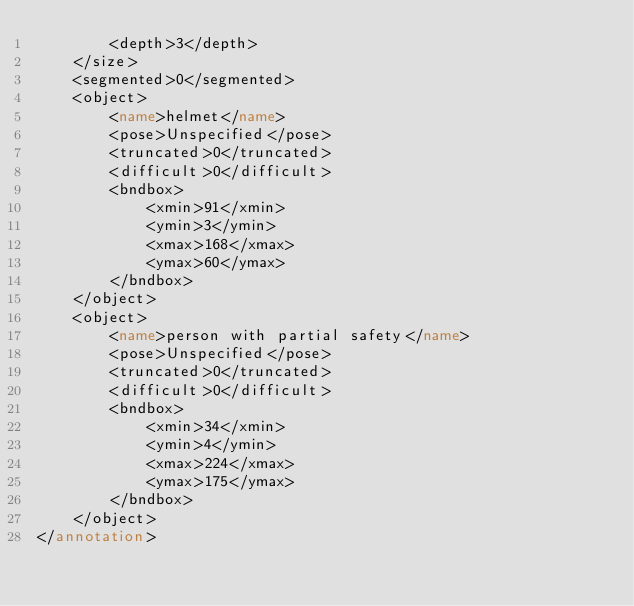Convert code to text. <code><loc_0><loc_0><loc_500><loc_500><_XML_>		<depth>3</depth>
	</size>
	<segmented>0</segmented>
	<object>
		<name>helmet</name>
		<pose>Unspecified</pose>
		<truncated>0</truncated>
		<difficult>0</difficult>
		<bndbox>
			<xmin>91</xmin>
			<ymin>3</ymin>
			<xmax>168</xmax>
			<ymax>60</ymax>
		</bndbox>
	</object>
	<object>
		<name>person with partial safety</name>
		<pose>Unspecified</pose>
		<truncated>0</truncated>
		<difficult>0</difficult>
		<bndbox>
			<xmin>34</xmin>
			<ymin>4</ymin>
			<xmax>224</xmax>
			<ymax>175</ymax>
		</bndbox>
	</object>
</annotation></code> 